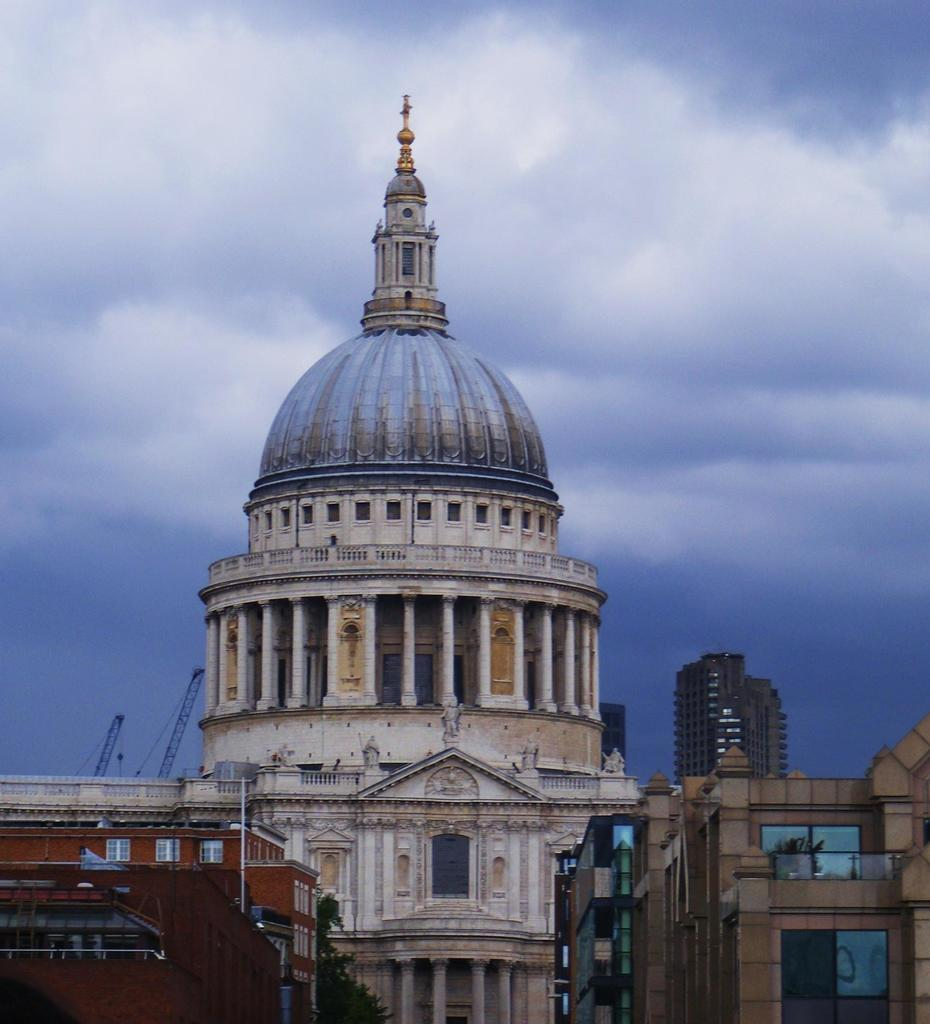What type of structures can be seen in the image? There are buildings in the image. What natural element is present at the bottom of the image? There is a tree at the bottom of the image. What is visible at the top of the image? The sky is visible at the top of the image. How many stories can be seen in the image? The provided facts do not mention the number of stories in the buildings, so it cannot be determined from the image. Are there any bikes visible in the image? There is no mention of bikes in the provided facts, so it cannot be determined if they are present in the image. 